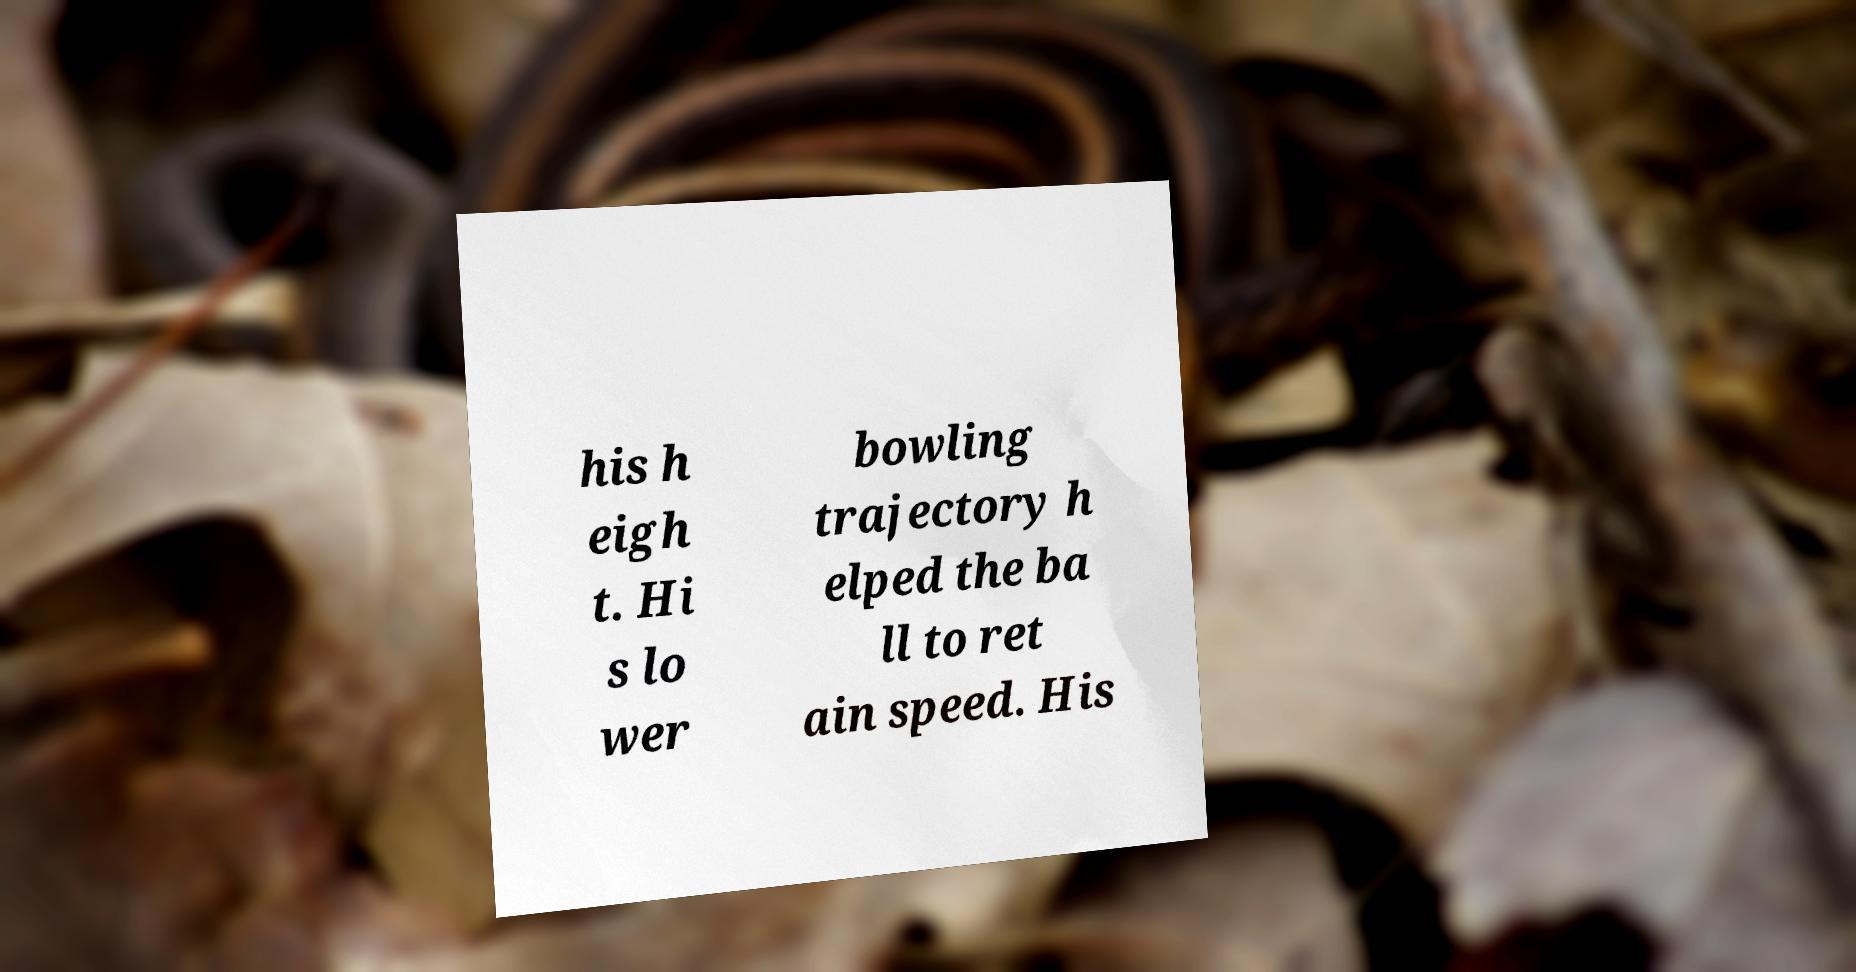Can you read and provide the text displayed in the image?This photo seems to have some interesting text. Can you extract and type it out for me? his h eigh t. Hi s lo wer bowling trajectory h elped the ba ll to ret ain speed. His 